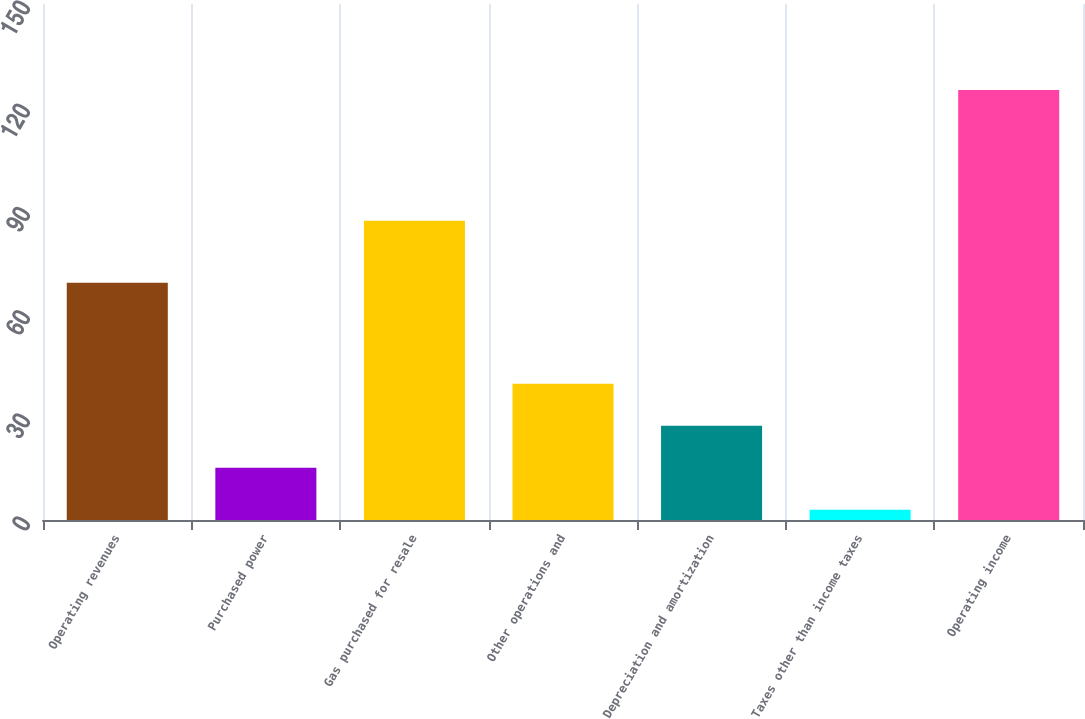Convert chart. <chart><loc_0><loc_0><loc_500><loc_500><bar_chart><fcel>Operating revenues<fcel>Purchased power<fcel>Gas purchased for resale<fcel>Other operations and<fcel>Depreciation and amortization<fcel>Taxes other than income taxes<fcel>Operating income<nl><fcel>69<fcel>15.2<fcel>87<fcel>39.6<fcel>27.4<fcel>3<fcel>125<nl></chart> 